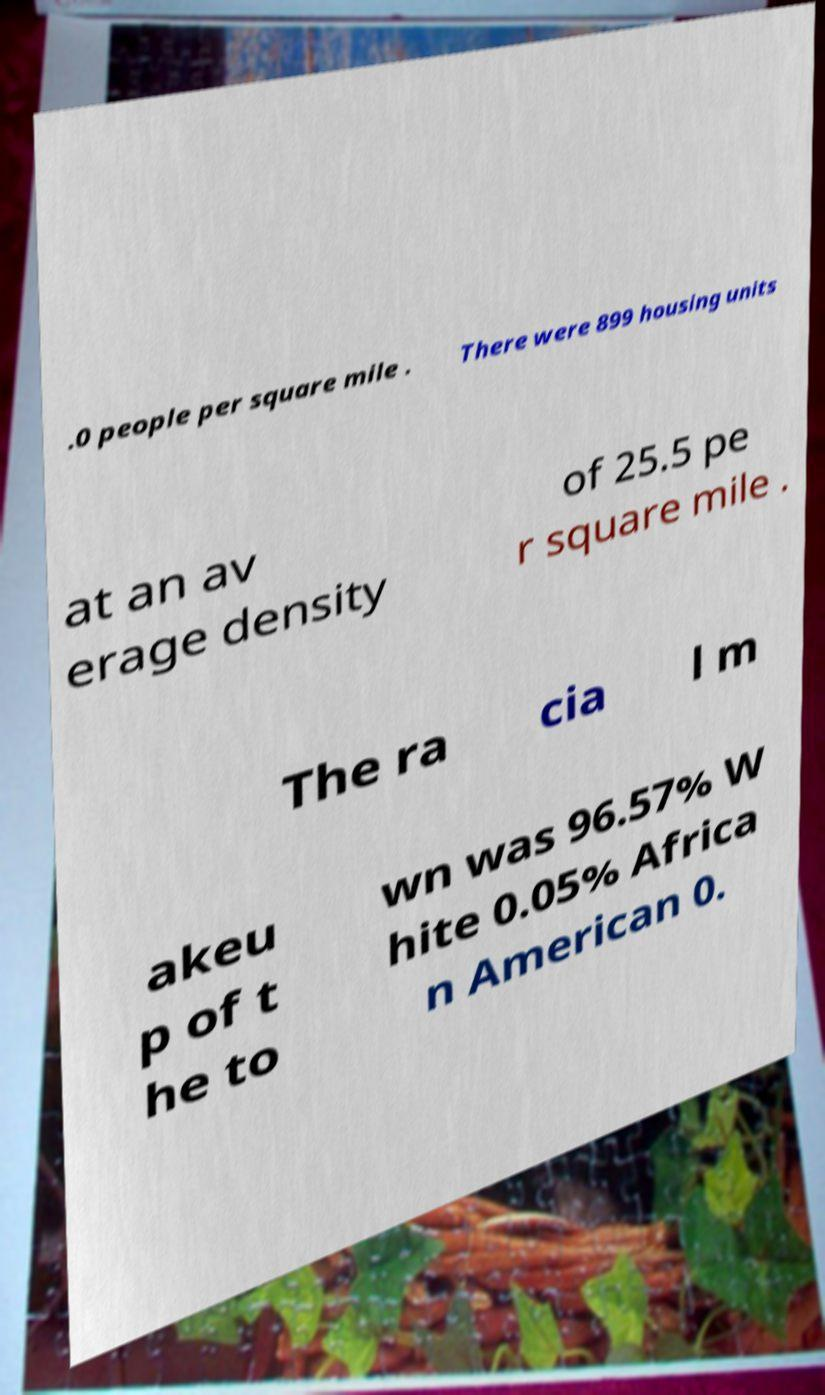I need the written content from this picture converted into text. Can you do that? .0 people per square mile . There were 899 housing units at an av erage density of 25.5 pe r square mile . The ra cia l m akeu p of t he to wn was 96.57% W hite 0.05% Africa n American 0. 